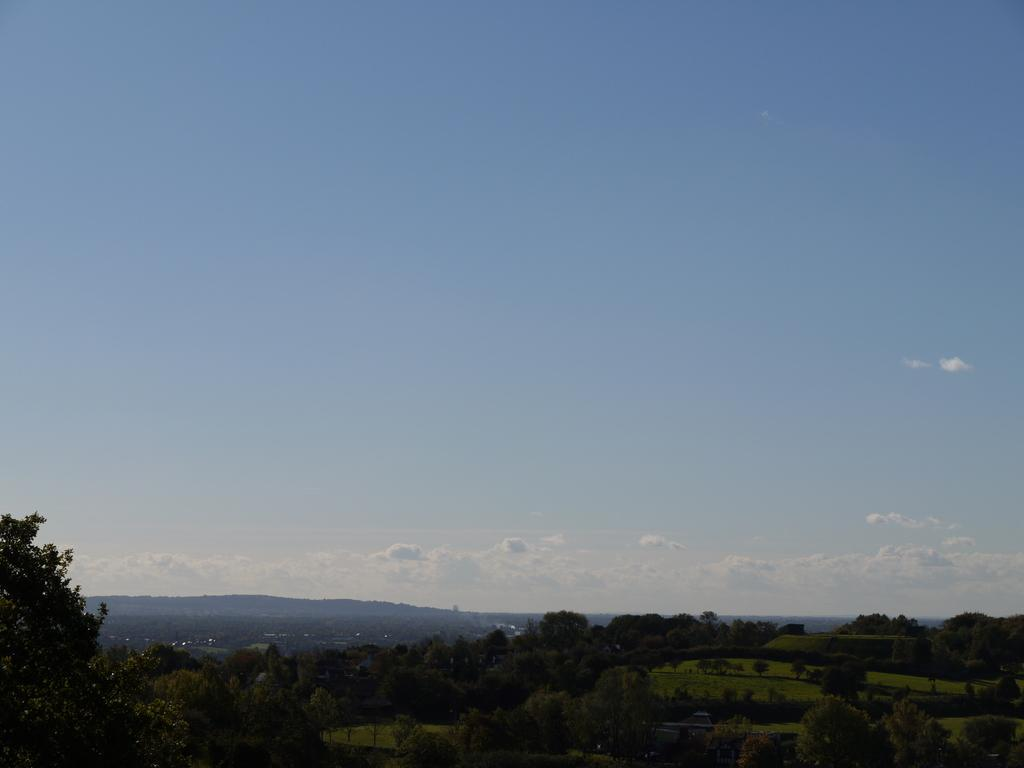What type of vegetation can be seen at the bottom of the image? There are trees at the bottom of the image. What geographical features are visible in the image? There are hills in the image. What type of ground cover is present in the image? Grass is present in the image. What is visible in the sky in the image? The sky is visible in the image, and clouds are present. What day of the week is it in the image? The day of the week is not mentioned or depicted in the image. What operation is being performed on the trees in the image? There is no operation being performed on the trees in the image; they are simply standing in their natural state. 